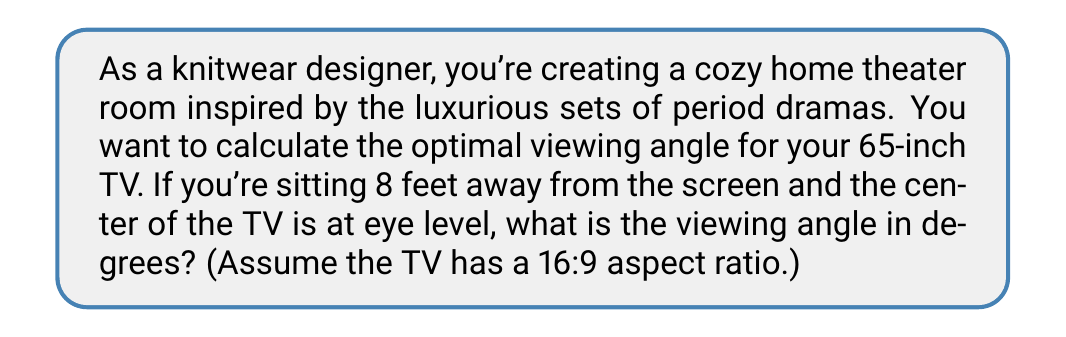Can you solve this math problem? Let's approach this step-by-step:

1) First, we need to calculate the width of the TV. For a 65-inch TV with a 16:9 aspect ratio:
   
   TV diagonal = 65 inches
   Width:Height ratio = 16:9
   
   Using the Pythagorean theorem:
   $$width^2 + (\frac{9}{16}width)^2 = 65^2$$
   
   $$width^2(1 + (\frac{9}{16})^2) = 65^2$$
   
   $$width = \sqrt{\frac{65^2}{1 + (\frac{9}{16})^2}} \approx 56.7 \text{ inches}$$

2) Convert the width to feet:
   $$56.7 \text{ inches} \times \frac{1 \text{ foot}}{12 \text{ inches}} \approx 4.73 \text{ feet}$$

3) The viewing distance is 8 feet, and half the TV width is the opposite side of our right triangle:
   $$\text{opposite} = \frac{4.73}{2} = 2.365 \text{ feet}$$

4) Now we can use the tangent function to find the angle:
   $$\tan(\theta) = \frac{\text{opposite}}{\text{adjacent}} = \frac{2.365}{8}$$

5) To find $\theta$, we use the inverse tangent (arctan):
   $$\theta = \arctan(\frac{2.365}{8})$$

6) Calculate the result:
   $$\theta \approx 16.5°$$

7) The full viewing angle is twice this angle:
   $$\text{Viewing Angle} = 2 \theta \approx 33.0°$$
Answer: $33.0°$ 